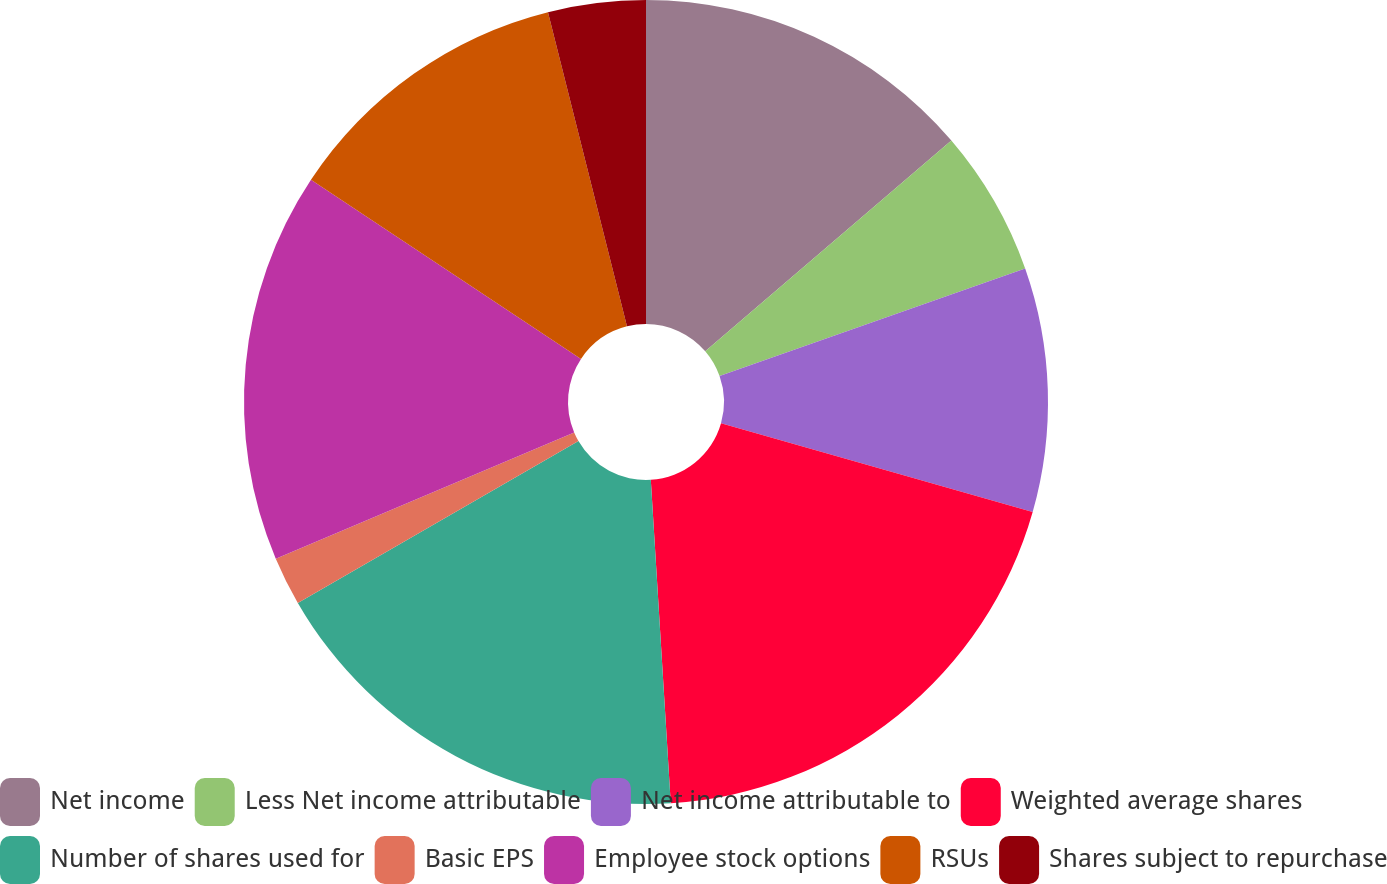<chart> <loc_0><loc_0><loc_500><loc_500><pie_chart><fcel>Net income<fcel>Less Net income attributable<fcel>Net income attributable to<fcel>Weighted average shares<fcel>Number of shares used for<fcel>Basic EPS<fcel>Employee stock options<fcel>RSUs<fcel>Shares subject to repurchase<nl><fcel>13.73%<fcel>5.88%<fcel>9.8%<fcel>19.61%<fcel>17.65%<fcel>1.96%<fcel>15.69%<fcel>11.76%<fcel>3.92%<nl></chart> 